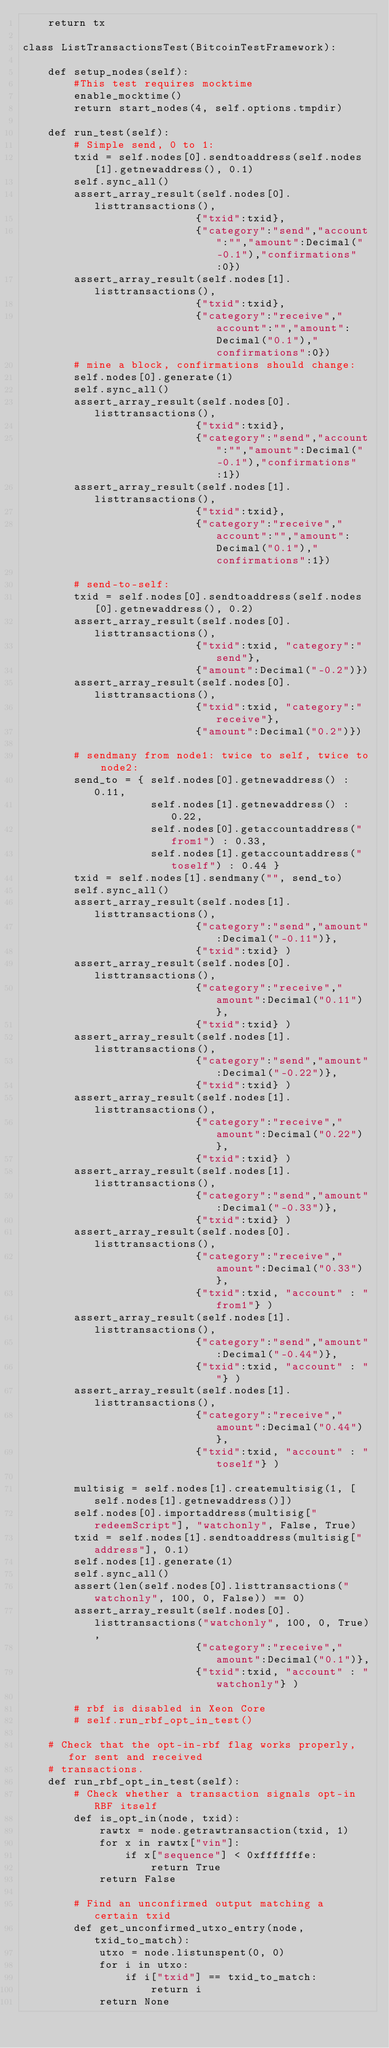Convert code to text. <code><loc_0><loc_0><loc_500><loc_500><_Python_>    return tx

class ListTransactionsTest(BitcoinTestFramework):

    def setup_nodes(self):
        #This test requires mocktime
        enable_mocktime()
        return start_nodes(4, self.options.tmpdir)

    def run_test(self):
        # Simple send, 0 to 1:
        txid = self.nodes[0].sendtoaddress(self.nodes[1].getnewaddress(), 0.1)
        self.sync_all()
        assert_array_result(self.nodes[0].listtransactions(),
                           {"txid":txid},
                           {"category":"send","account":"","amount":Decimal("-0.1"),"confirmations":0})
        assert_array_result(self.nodes[1].listtransactions(),
                           {"txid":txid},
                           {"category":"receive","account":"","amount":Decimal("0.1"),"confirmations":0})
        # mine a block, confirmations should change:
        self.nodes[0].generate(1)
        self.sync_all()
        assert_array_result(self.nodes[0].listtransactions(),
                           {"txid":txid},
                           {"category":"send","account":"","amount":Decimal("-0.1"),"confirmations":1})
        assert_array_result(self.nodes[1].listtransactions(),
                           {"txid":txid},
                           {"category":"receive","account":"","amount":Decimal("0.1"),"confirmations":1})

        # send-to-self:
        txid = self.nodes[0].sendtoaddress(self.nodes[0].getnewaddress(), 0.2)
        assert_array_result(self.nodes[0].listtransactions(),
                           {"txid":txid, "category":"send"},
                           {"amount":Decimal("-0.2")})
        assert_array_result(self.nodes[0].listtransactions(),
                           {"txid":txid, "category":"receive"},
                           {"amount":Decimal("0.2")})

        # sendmany from node1: twice to self, twice to node2:
        send_to = { self.nodes[0].getnewaddress() : 0.11,
                    self.nodes[1].getnewaddress() : 0.22,
                    self.nodes[0].getaccountaddress("from1") : 0.33,
                    self.nodes[1].getaccountaddress("toself") : 0.44 }
        txid = self.nodes[1].sendmany("", send_to)
        self.sync_all()
        assert_array_result(self.nodes[1].listtransactions(),
                           {"category":"send","amount":Decimal("-0.11")},
                           {"txid":txid} )
        assert_array_result(self.nodes[0].listtransactions(),
                           {"category":"receive","amount":Decimal("0.11")},
                           {"txid":txid} )
        assert_array_result(self.nodes[1].listtransactions(),
                           {"category":"send","amount":Decimal("-0.22")},
                           {"txid":txid} )
        assert_array_result(self.nodes[1].listtransactions(),
                           {"category":"receive","amount":Decimal("0.22")},
                           {"txid":txid} )
        assert_array_result(self.nodes[1].listtransactions(),
                           {"category":"send","amount":Decimal("-0.33")},
                           {"txid":txid} )
        assert_array_result(self.nodes[0].listtransactions(),
                           {"category":"receive","amount":Decimal("0.33")},
                           {"txid":txid, "account" : "from1"} )
        assert_array_result(self.nodes[1].listtransactions(),
                           {"category":"send","amount":Decimal("-0.44")},
                           {"txid":txid, "account" : ""} )
        assert_array_result(self.nodes[1].listtransactions(),
                           {"category":"receive","amount":Decimal("0.44")},
                           {"txid":txid, "account" : "toself"} )

        multisig = self.nodes[1].createmultisig(1, [self.nodes[1].getnewaddress()])
        self.nodes[0].importaddress(multisig["redeemScript"], "watchonly", False, True)
        txid = self.nodes[1].sendtoaddress(multisig["address"], 0.1)
        self.nodes[1].generate(1)
        self.sync_all()
        assert(len(self.nodes[0].listtransactions("watchonly", 100, 0, False)) == 0)
        assert_array_result(self.nodes[0].listtransactions("watchonly", 100, 0, True),
                           {"category":"receive","amount":Decimal("0.1")},
                           {"txid":txid, "account" : "watchonly"} )

        # rbf is disabled in Xeon Core
        # self.run_rbf_opt_in_test()

    # Check that the opt-in-rbf flag works properly, for sent and received
    # transactions.
    def run_rbf_opt_in_test(self):
        # Check whether a transaction signals opt-in RBF itself
        def is_opt_in(node, txid):
            rawtx = node.getrawtransaction(txid, 1)
            for x in rawtx["vin"]:
                if x["sequence"] < 0xfffffffe:
                    return True
            return False

        # Find an unconfirmed output matching a certain txid
        def get_unconfirmed_utxo_entry(node, txid_to_match):
            utxo = node.listunspent(0, 0)
            for i in utxo:
                if i["txid"] == txid_to_match:
                    return i
            return None
</code> 